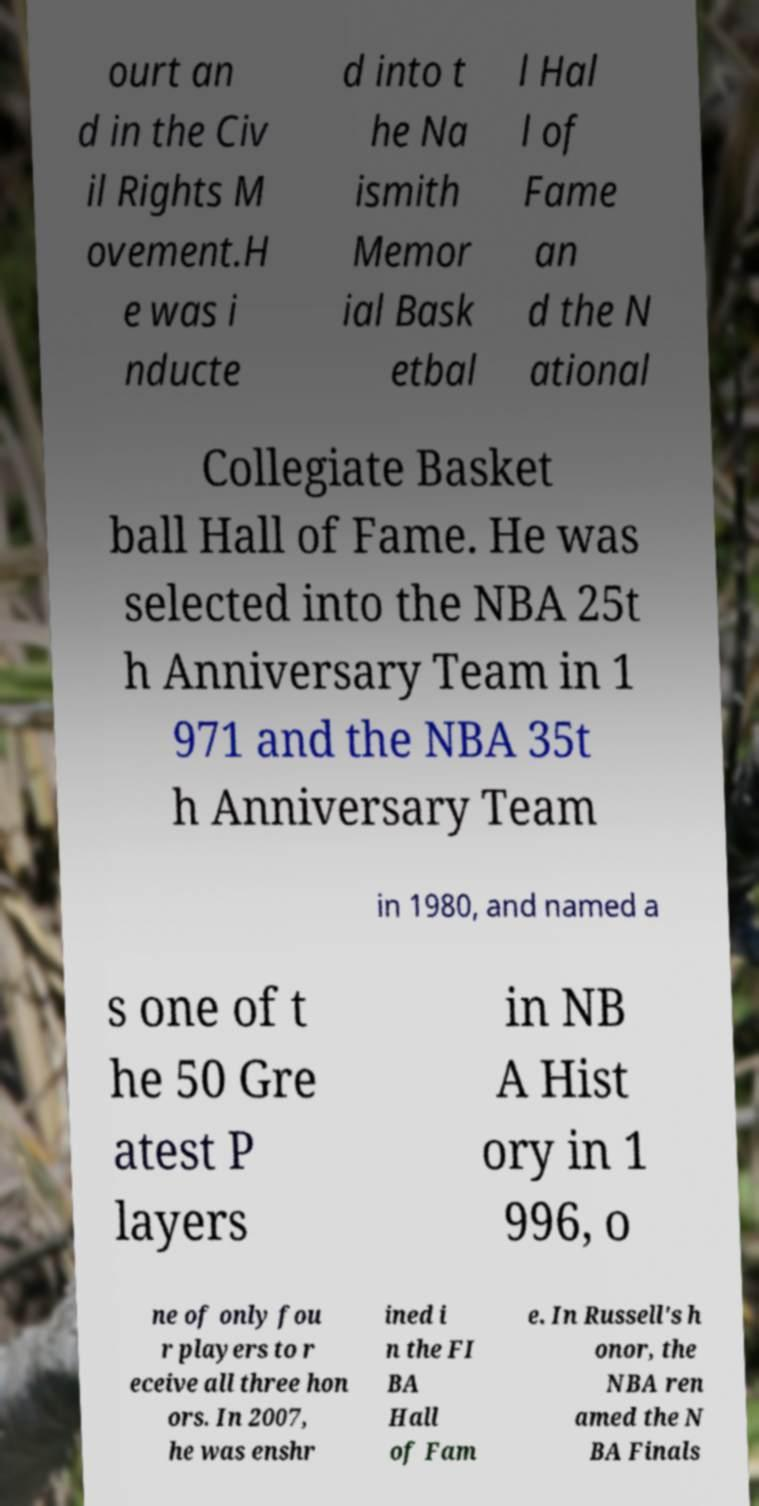Can you accurately transcribe the text from the provided image for me? ourt an d in the Civ il Rights M ovement.H e was i nducte d into t he Na ismith Memor ial Bask etbal l Hal l of Fame an d the N ational Collegiate Basket ball Hall of Fame. He was selected into the NBA 25t h Anniversary Team in 1 971 and the NBA 35t h Anniversary Team in 1980, and named a s one of t he 50 Gre atest P layers in NB A Hist ory in 1 996, o ne of only fou r players to r eceive all three hon ors. In 2007, he was enshr ined i n the FI BA Hall of Fam e. In Russell's h onor, the NBA ren amed the N BA Finals 